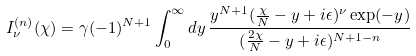Convert formula to latex. <formula><loc_0><loc_0><loc_500><loc_500>I ^ { ( n ) } _ { \nu } ( \chi ) = \gamma ( - 1 ) ^ { N + 1 } \int _ { 0 } ^ { \infty } d y \, \frac { y ^ { N + 1 } ( \frac { \chi } { N } - y + i \epsilon ) ^ { \nu } \exp ( - y ) } { ( \frac { 2 \chi } { N } - y + i \epsilon ) ^ { N + 1 - n } }</formula> 